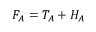Convert formula to latex. <formula><loc_0><loc_0><loc_500><loc_500>\begin{array} { r } { F _ { A } = T _ { A } + H _ { A } } \end{array}</formula> 